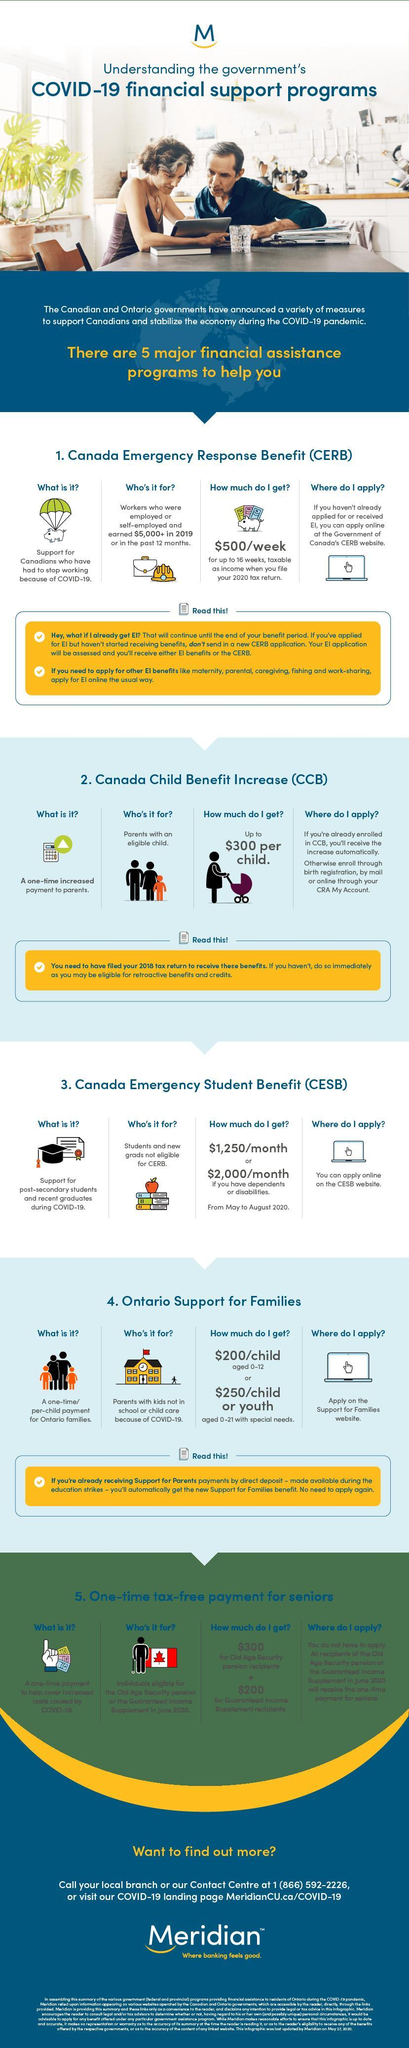How much is the financial assistance offered by the Canada Child Benefit Increase program?
Answer the question with a short phrase. Up to $300 per child. Which financial assistance program is announced by the Canadian government to support Canadians who had to stop working because of COVID-19? Canada Emergency Response Benefit (CERB) Which financial assistance program is announced by the Canadian government to support post-secondary students & recent graduates during COVID-19? Canada Emergency Student Benefit (CESB) 